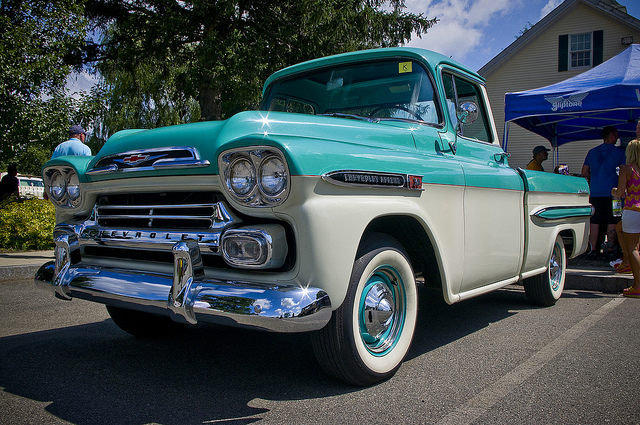Where might this truck be typically found in modern times? This classic Chevrolet truck would likely be found at car shows, vintage automobile collections, or parades. It may also belong to an enthusiast who enjoys participating in classic car tours or simply showcasing it at local events. Due to its restored and well-maintained condition, it is a prized possession that is more often displayed than used for daily transportation. 